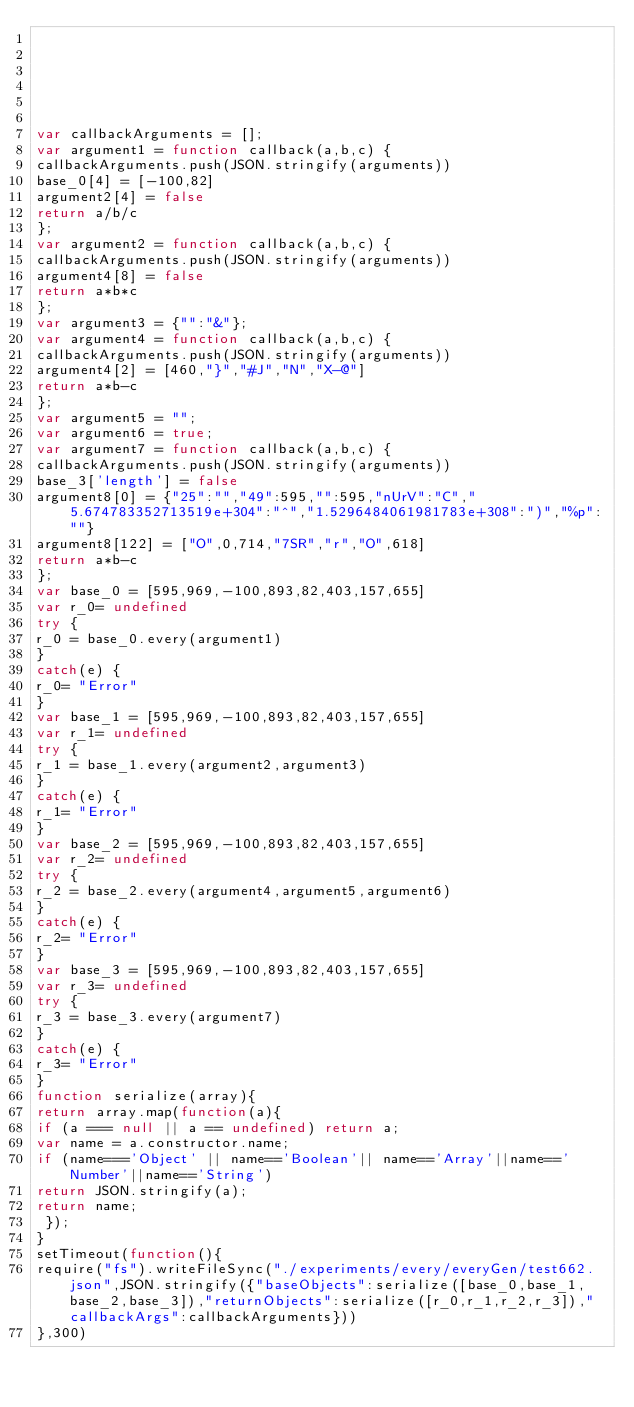<code> <loc_0><loc_0><loc_500><loc_500><_JavaScript_>





var callbackArguments = [];
var argument1 = function callback(a,b,c) { 
callbackArguments.push(JSON.stringify(arguments))
base_0[4] = [-100,82]
argument2[4] = false
return a/b/c
};
var argument2 = function callback(a,b,c) { 
callbackArguments.push(JSON.stringify(arguments))
argument4[8] = false
return a*b*c
};
var argument3 = {"":"&"};
var argument4 = function callback(a,b,c) { 
callbackArguments.push(JSON.stringify(arguments))
argument4[2] = [460,"}","#J","N","X-@"]
return a*b-c
};
var argument5 = "";
var argument6 = true;
var argument7 = function callback(a,b,c) { 
callbackArguments.push(JSON.stringify(arguments))
base_3['length'] = false
argument8[0] = {"25":"","49":595,"":595,"nUrV":"C","5.674783352713519e+304":"^","1.5296484061981783e+308":")","%p":""}
argument8[122] = ["O",0,714,"7SR","r","O",618]
return a*b-c
};
var base_0 = [595,969,-100,893,82,403,157,655]
var r_0= undefined
try {
r_0 = base_0.every(argument1)
}
catch(e) {
r_0= "Error"
}
var base_1 = [595,969,-100,893,82,403,157,655]
var r_1= undefined
try {
r_1 = base_1.every(argument2,argument3)
}
catch(e) {
r_1= "Error"
}
var base_2 = [595,969,-100,893,82,403,157,655]
var r_2= undefined
try {
r_2 = base_2.every(argument4,argument5,argument6)
}
catch(e) {
r_2= "Error"
}
var base_3 = [595,969,-100,893,82,403,157,655]
var r_3= undefined
try {
r_3 = base_3.every(argument7)
}
catch(e) {
r_3= "Error"
}
function serialize(array){
return array.map(function(a){
if (a === null || a == undefined) return a;
var name = a.constructor.name;
if (name==='Object' || name=='Boolean'|| name=='Array'||name=='Number'||name=='String')
return JSON.stringify(a);
return name;
 });
}
setTimeout(function(){
require("fs").writeFileSync("./experiments/every/everyGen/test662.json",JSON.stringify({"baseObjects":serialize([base_0,base_1,base_2,base_3]),"returnObjects":serialize([r_0,r_1,r_2,r_3]),"callbackArgs":callbackArguments}))
},300)</code> 